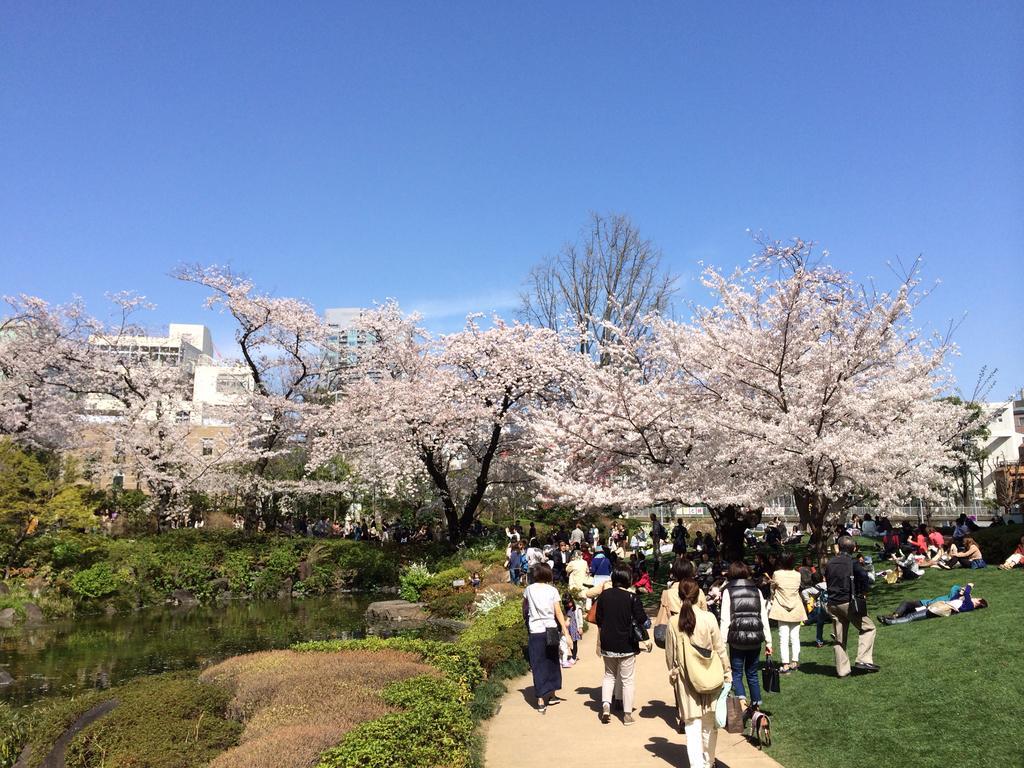Describe this image in one or two sentences. In this image, we can see so many trees, plants, grass, water, a group of people. Few are walking on the walkway. Few are lying, sitting and standing. Here we can see few buildings. Background there is a sky. 